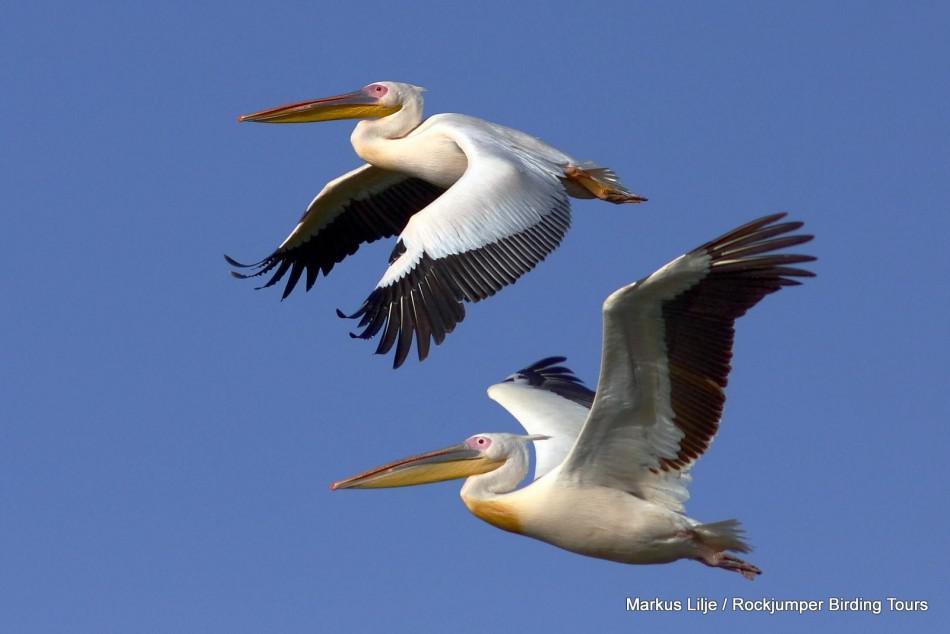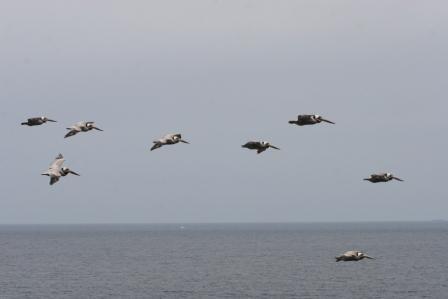The first image is the image on the left, the second image is the image on the right. For the images shown, is this caption "Two birds are flying to the left in the image on the left." true? Answer yes or no. Yes. The first image is the image on the left, the second image is the image on the right. Evaluate the accuracy of this statement regarding the images: "All of the birds in both images are flying rightward.". Is it true? Answer yes or no. No. 